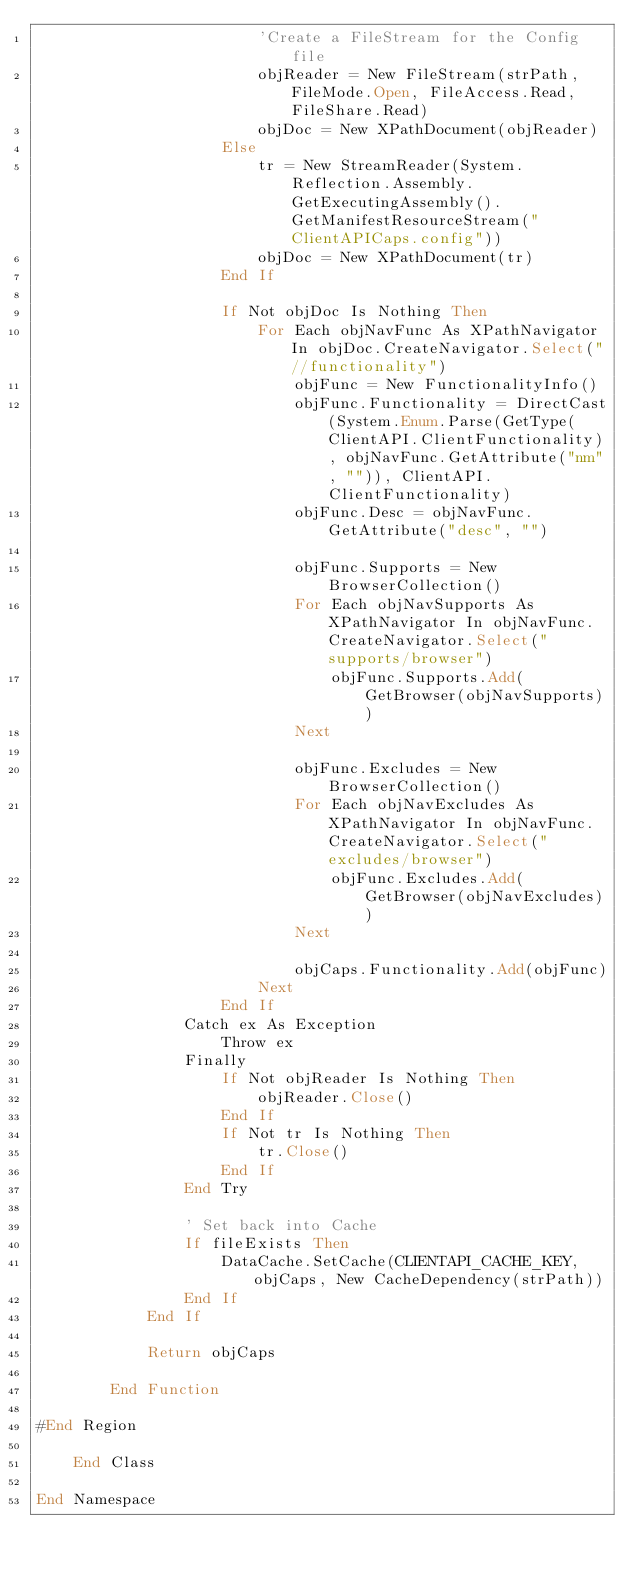Convert code to text. <code><loc_0><loc_0><loc_500><loc_500><_VisualBasic_>                        'Create a FileStream for the Config file
                        objReader = New FileStream(strPath, FileMode.Open, FileAccess.Read, FileShare.Read)
                        objDoc = New XPathDocument(objReader)
                    Else
                        tr = New StreamReader(System.Reflection.Assembly.GetExecutingAssembly().GetManifestResourceStream("ClientAPICaps.config"))
                        objDoc = New XPathDocument(tr)
                    End If

                    If Not objDoc Is Nothing Then
                        For Each objNavFunc As XPathNavigator In objDoc.CreateNavigator.Select("//functionality")
                            objFunc = New FunctionalityInfo()
                            objFunc.Functionality = DirectCast(System.Enum.Parse(GetType(ClientAPI.ClientFunctionality), objNavFunc.GetAttribute("nm", "")), ClientAPI.ClientFunctionality)
                            objFunc.Desc = objNavFunc.GetAttribute("desc", "")

                            objFunc.Supports = New BrowserCollection()
                            For Each objNavSupports As XPathNavigator In objNavFunc.CreateNavigator.Select("supports/browser")
                                objFunc.Supports.Add(GetBrowser(objNavSupports))
                            Next

                            objFunc.Excludes = New BrowserCollection()
                            For Each objNavExcludes As XPathNavigator In objNavFunc.CreateNavigator.Select("excludes/browser")
                                objFunc.Excludes.Add(GetBrowser(objNavExcludes))
                            Next

                            objCaps.Functionality.Add(objFunc)
                        Next
                    End If
                Catch ex As Exception
                    Throw ex
                Finally
                    If Not objReader Is Nothing Then
                        objReader.Close()
                    End If
                    If Not tr Is Nothing Then
                        tr.Close()
                    End If
                End Try

                ' Set back into Cache
                If fileExists Then
                    DataCache.SetCache(CLIENTAPI_CACHE_KEY, objCaps, New CacheDependency(strPath))
                End If
            End If

            Return objCaps

        End Function

#End Region

    End Class

End Namespace
</code> 